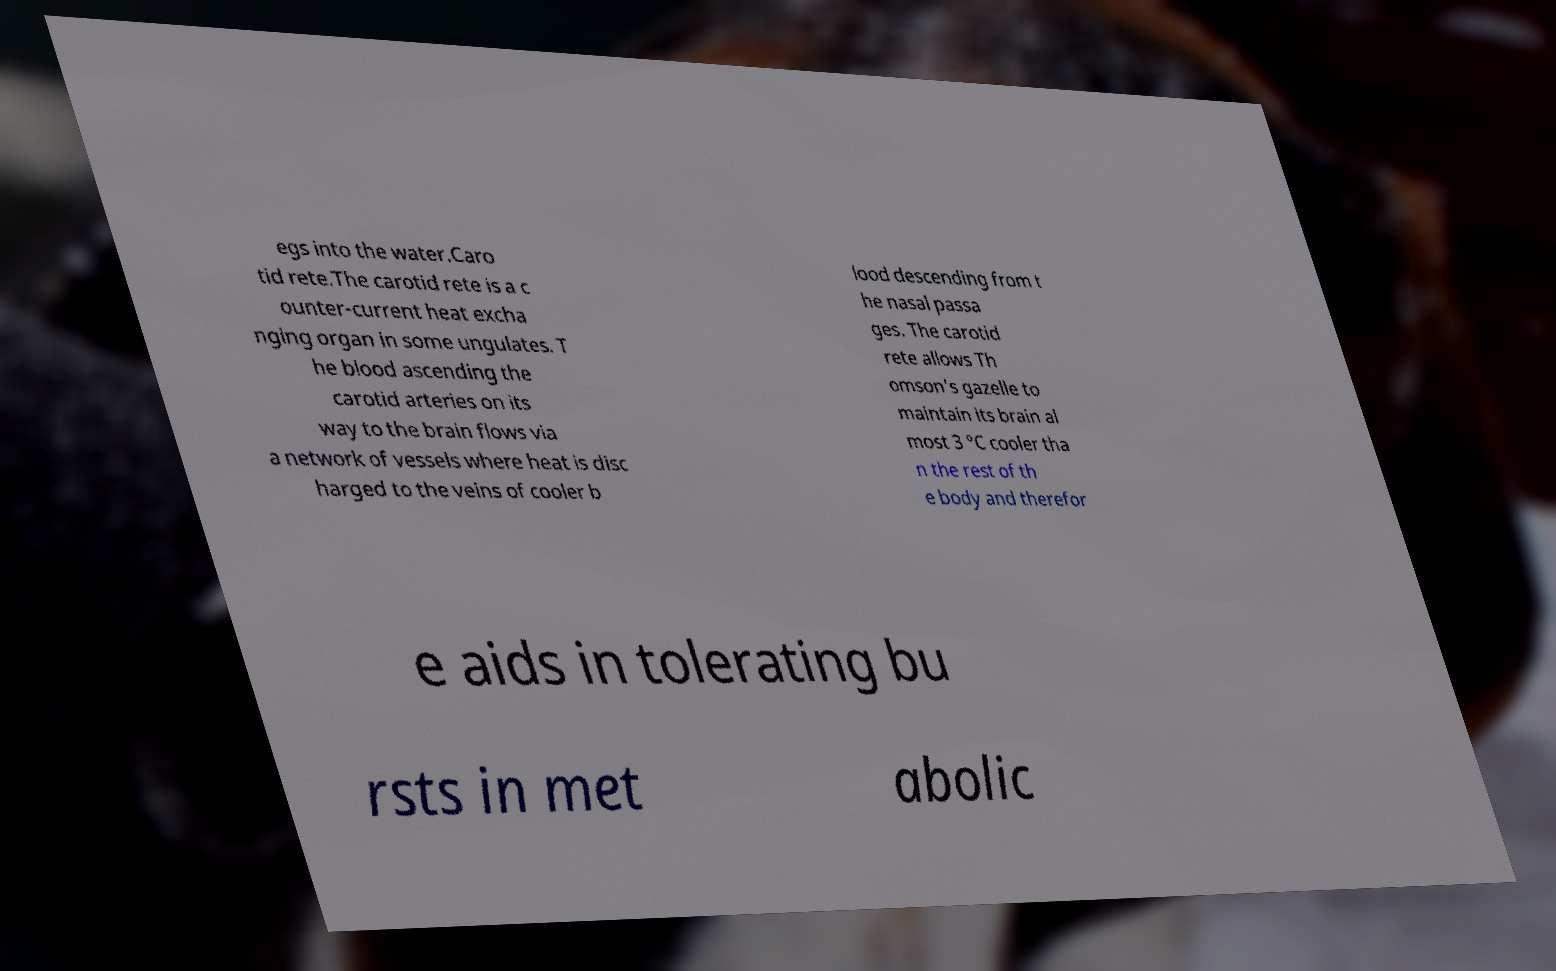For documentation purposes, I need the text within this image transcribed. Could you provide that? egs into the water.Caro tid rete.The carotid rete is a c ounter-current heat excha nging organ in some ungulates. T he blood ascending the carotid arteries on its way to the brain flows via a network of vessels where heat is disc harged to the veins of cooler b lood descending from t he nasal passa ges. The carotid rete allows Th omson's gazelle to maintain its brain al most 3 °C cooler tha n the rest of th e body and therefor e aids in tolerating bu rsts in met abolic 